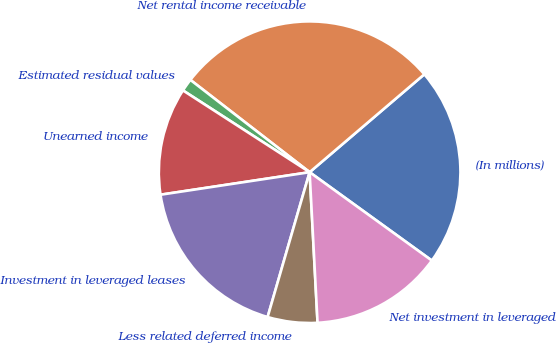Convert chart to OTSL. <chart><loc_0><loc_0><loc_500><loc_500><pie_chart><fcel>(In millions)<fcel>Net rental income receivable<fcel>Estimated residual values<fcel>Unearned income<fcel>Investment in leveraged leases<fcel>Less related deferred income<fcel>Net investment in leveraged<nl><fcel>21.21%<fcel>28.27%<fcel>1.36%<fcel>11.51%<fcel>18.12%<fcel>5.33%<fcel>14.2%<nl></chart> 